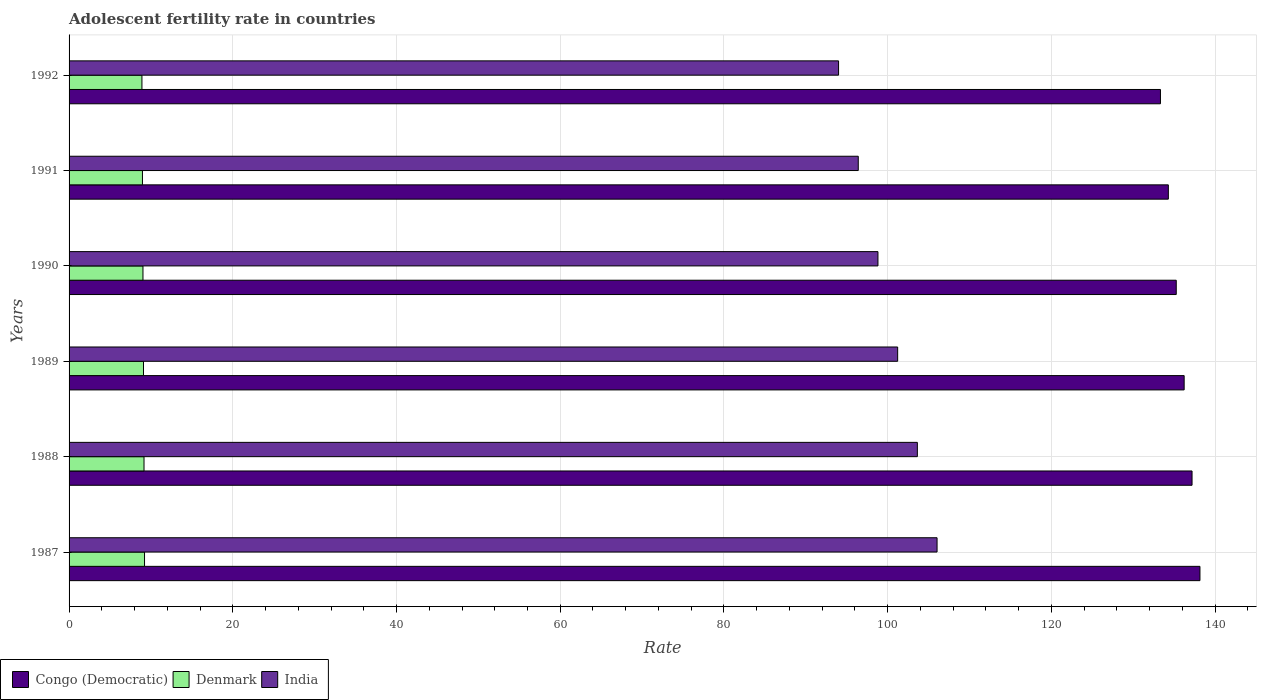How many different coloured bars are there?
Your response must be concise. 3. How many groups of bars are there?
Make the answer very short. 6. How many bars are there on the 6th tick from the top?
Ensure brevity in your answer.  3. How many bars are there on the 6th tick from the bottom?
Make the answer very short. 3. What is the label of the 5th group of bars from the top?
Make the answer very short. 1988. What is the adolescent fertility rate in India in 1989?
Keep it short and to the point. 101.22. Across all years, what is the maximum adolescent fertility rate in Denmark?
Offer a very short reply. 9.22. Across all years, what is the minimum adolescent fertility rate in Denmark?
Provide a short and direct response. 8.9. In which year was the adolescent fertility rate in Congo (Democratic) maximum?
Your answer should be very brief. 1987. In which year was the adolescent fertility rate in Denmark minimum?
Offer a very short reply. 1992. What is the total adolescent fertility rate in Congo (Democratic) in the graph?
Your answer should be compact. 814.41. What is the difference between the adolescent fertility rate in Denmark in 1988 and that in 1989?
Your answer should be very brief. 0.06. What is the difference between the adolescent fertility rate in India in 1990 and the adolescent fertility rate in Denmark in 1991?
Provide a short and direct response. 89.85. What is the average adolescent fertility rate in Congo (Democratic) per year?
Keep it short and to the point. 135.73. In the year 1987, what is the difference between the adolescent fertility rate in Denmark and adolescent fertility rate in India?
Keep it short and to the point. -96.81. What is the ratio of the adolescent fertility rate in India in 1988 to that in 1991?
Make the answer very short. 1.07. Is the adolescent fertility rate in India in 1988 less than that in 1991?
Provide a succinct answer. No. What is the difference between the highest and the second highest adolescent fertility rate in Denmark?
Your answer should be compact. 0.06. What is the difference between the highest and the lowest adolescent fertility rate in Congo (Democratic)?
Offer a terse response. 4.82. In how many years, is the adolescent fertility rate in India greater than the average adolescent fertility rate in India taken over all years?
Offer a terse response. 3. What does the 2nd bar from the top in 1992 represents?
Make the answer very short. Denmark. What does the 3rd bar from the bottom in 1987 represents?
Your response must be concise. India. How many bars are there?
Provide a succinct answer. 18. Are all the bars in the graph horizontal?
Give a very brief answer. Yes. What is the difference between two consecutive major ticks on the X-axis?
Your answer should be compact. 20. Does the graph contain grids?
Provide a succinct answer. Yes. What is the title of the graph?
Offer a very short reply. Adolescent fertility rate in countries. Does "Thailand" appear as one of the legend labels in the graph?
Offer a very short reply. No. What is the label or title of the X-axis?
Your answer should be very brief. Rate. What is the Rate in Congo (Democratic) in 1987?
Ensure brevity in your answer.  138.15. What is the Rate of Denmark in 1987?
Keep it short and to the point. 9.22. What is the Rate in India in 1987?
Offer a terse response. 106.03. What is the Rate of Congo (Democratic) in 1988?
Your answer should be very brief. 137.18. What is the Rate in Denmark in 1988?
Your answer should be very brief. 9.16. What is the Rate of India in 1988?
Provide a short and direct response. 103.63. What is the Rate of Congo (Democratic) in 1989?
Your answer should be compact. 136.22. What is the Rate of Denmark in 1989?
Your answer should be very brief. 9.09. What is the Rate of India in 1989?
Your answer should be compact. 101.22. What is the Rate of Congo (Democratic) in 1990?
Ensure brevity in your answer.  135.25. What is the Rate of Denmark in 1990?
Your answer should be very brief. 9.03. What is the Rate in India in 1990?
Make the answer very short. 98.81. What is the Rate in Congo (Democratic) in 1991?
Provide a short and direct response. 134.29. What is the Rate of Denmark in 1991?
Your answer should be very brief. 8.96. What is the Rate in India in 1991?
Your answer should be compact. 96.41. What is the Rate in Congo (Democratic) in 1992?
Give a very brief answer. 133.32. What is the Rate in Denmark in 1992?
Offer a terse response. 8.9. What is the Rate of India in 1992?
Give a very brief answer. 94. Across all years, what is the maximum Rate in Congo (Democratic)?
Ensure brevity in your answer.  138.15. Across all years, what is the maximum Rate of Denmark?
Keep it short and to the point. 9.22. Across all years, what is the maximum Rate of India?
Provide a short and direct response. 106.03. Across all years, what is the minimum Rate in Congo (Democratic)?
Ensure brevity in your answer.  133.32. Across all years, what is the minimum Rate in Denmark?
Offer a very short reply. 8.9. Across all years, what is the minimum Rate of India?
Provide a succinct answer. 94. What is the total Rate in Congo (Democratic) in the graph?
Make the answer very short. 814.41. What is the total Rate of Denmark in the graph?
Offer a terse response. 54.36. What is the total Rate in India in the graph?
Give a very brief answer. 600.1. What is the difference between the Rate of Congo (Democratic) in 1987 and that in 1988?
Provide a short and direct response. 0.96. What is the difference between the Rate in Denmark in 1987 and that in 1988?
Provide a succinct answer. 0.06. What is the difference between the Rate of India in 1987 and that in 1988?
Your answer should be compact. 2.41. What is the difference between the Rate of Congo (Democratic) in 1987 and that in 1989?
Offer a very short reply. 1.93. What is the difference between the Rate of Denmark in 1987 and that in 1989?
Ensure brevity in your answer.  0.13. What is the difference between the Rate in India in 1987 and that in 1989?
Make the answer very short. 4.81. What is the difference between the Rate in Congo (Democratic) in 1987 and that in 1990?
Provide a short and direct response. 2.9. What is the difference between the Rate in Denmark in 1987 and that in 1990?
Provide a succinct answer. 0.19. What is the difference between the Rate of India in 1987 and that in 1990?
Provide a short and direct response. 7.22. What is the difference between the Rate of Congo (Democratic) in 1987 and that in 1991?
Offer a terse response. 3.86. What is the difference between the Rate in Denmark in 1987 and that in 1991?
Ensure brevity in your answer.  0.25. What is the difference between the Rate of India in 1987 and that in 1991?
Keep it short and to the point. 9.63. What is the difference between the Rate of Congo (Democratic) in 1987 and that in 1992?
Offer a very short reply. 4.83. What is the difference between the Rate of Denmark in 1987 and that in 1992?
Your answer should be very brief. 0.32. What is the difference between the Rate in India in 1987 and that in 1992?
Give a very brief answer. 12.03. What is the difference between the Rate of Denmark in 1988 and that in 1989?
Your answer should be compact. 0.06. What is the difference between the Rate of India in 1988 and that in 1989?
Your answer should be very brief. 2.41. What is the difference between the Rate in Congo (Democratic) in 1988 and that in 1990?
Provide a short and direct response. 1.93. What is the difference between the Rate in Denmark in 1988 and that in 1990?
Keep it short and to the point. 0.13. What is the difference between the Rate of India in 1988 and that in 1990?
Keep it short and to the point. 4.81. What is the difference between the Rate of Congo (Democratic) in 1988 and that in 1991?
Offer a terse response. 2.9. What is the difference between the Rate of Denmark in 1988 and that in 1991?
Make the answer very short. 0.19. What is the difference between the Rate of India in 1988 and that in 1991?
Offer a very short reply. 7.22. What is the difference between the Rate of Congo (Democratic) in 1988 and that in 1992?
Provide a short and direct response. 3.86. What is the difference between the Rate of Denmark in 1988 and that in 1992?
Your answer should be compact. 0.25. What is the difference between the Rate in India in 1988 and that in 1992?
Ensure brevity in your answer.  9.63. What is the difference between the Rate in Congo (Democratic) in 1989 and that in 1990?
Offer a terse response. 0.96. What is the difference between the Rate of Denmark in 1989 and that in 1990?
Provide a succinct answer. 0.06. What is the difference between the Rate of India in 1989 and that in 1990?
Make the answer very short. 2.41. What is the difference between the Rate in Congo (Democratic) in 1989 and that in 1991?
Make the answer very short. 1.93. What is the difference between the Rate of Denmark in 1989 and that in 1991?
Make the answer very short. 0.13. What is the difference between the Rate of India in 1989 and that in 1991?
Ensure brevity in your answer.  4.81. What is the difference between the Rate in Congo (Democratic) in 1989 and that in 1992?
Give a very brief answer. 2.9. What is the difference between the Rate in Denmark in 1989 and that in 1992?
Ensure brevity in your answer.  0.19. What is the difference between the Rate of India in 1989 and that in 1992?
Your response must be concise. 7.22. What is the difference between the Rate of Congo (Democratic) in 1990 and that in 1991?
Your answer should be compact. 0.96. What is the difference between the Rate of Denmark in 1990 and that in 1991?
Ensure brevity in your answer.  0.06. What is the difference between the Rate in India in 1990 and that in 1991?
Your response must be concise. 2.41. What is the difference between the Rate in Congo (Democratic) in 1990 and that in 1992?
Your answer should be very brief. 1.93. What is the difference between the Rate in Denmark in 1990 and that in 1992?
Your answer should be very brief. 0.13. What is the difference between the Rate of India in 1990 and that in 1992?
Make the answer very short. 4.81. What is the difference between the Rate in Congo (Democratic) in 1991 and that in 1992?
Provide a short and direct response. 0.96. What is the difference between the Rate of Denmark in 1991 and that in 1992?
Make the answer very short. 0.06. What is the difference between the Rate of India in 1991 and that in 1992?
Offer a very short reply. 2.41. What is the difference between the Rate in Congo (Democratic) in 1987 and the Rate in Denmark in 1988?
Ensure brevity in your answer.  128.99. What is the difference between the Rate of Congo (Democratic) in 1987 and the Rate of India in 1988?
Provide a succinct answer. 34.52. What is the difference between the Rate of Denmark in 1987 and the Rate of India in 1988?
Provide a short and direct response. -94.41. What is the difference between the Rate in Congo (Democratic) in 1987 and the Rate in Denmark in 1989?
Your answer should be compact. 129.06. What is the difference between the Rate in Congo (Democratic) in 1987 and the Rate in India in 1989?
Your answer should be very brief. 36.93. What is the difference between the Rate in Denmark in 1987 and the Rate in India in 1989?
Provide a short and direct response. -92. What is the difference between the Rate in Congo (Democratic) in 1987 and the Rate in Denmark in 1990?
Offer a terse response. 129.12. What is the difference between the Rate of Congo (Democratic) in 1987 and the Rate of India in 1990?
Make the answer very short. 39.33. What is the difference between the Rate of Denmark in 1987 and the Rate of India in 1990?
Offer a very short reply. -89.59. What is the difference between the Rate of Congo (Democratic) in 1987 and the Rate of Denmark in 1991?
Your answer should be very brief. 129.18. What is the difference between the Rate of Congo (Democratic) in 1987 and the Rate of India in 1991?
Keep it short and to the point. 41.74. What is the difference between the Rate in Denmark in 1987 and the Rate in India in 1991?
Offer a terse response. -87.19. What is the difference between the Rate of Congo (Democratic) in 1987 and the Rate of Denmark in 1992?
Your answer should be very brief. 129.25. What is the difference between the Rate of Congo (Democratic) in 1987 and the Rate of India in 1992?
Your response must be concise. 44.15. What is the difference between the Rate of Denmark in 1987 and the Rate of India in 1992?
Offer a terse response. -84.78. What is the difference between the Rate in Congo (Democratic) in 1988 and the Rate in Denmark in 1989?
Provide a short and direct response. 128.09. What is the difference between the Rate in Congo (Democratic) in 1988 and the Rate in India in 1989?
Your answer should be very brief. 35.96. What is the difference between the Rate in Denmark in 1988 and the Rate in India in 1989?
Give a very brief answer. -92.06. What is the difference between the Rate of Congo (Democratic) in 1988 and the Rate of Denmark in 1990?
Offer a terse response. 128.15. What is the difference between the Rate in Congo (Democratic) in 1988 and the Rate in India in 1990?
Your answer should be compact. 38.37. What is the difference between the Rate in Denmark in 1988 and the Rate in India in 1990?
Your answer should be very brief. -89.66. What is the difference between the Rate in Congo (Democratic) in 1988 and the Rate in Denmark in 1991?
Provide a short and direct response. 128.22. What is the difference between the Rate of Congo (Democratic) in 1988 and the Rate of India in 1991?
Your answer should be compact. 40.78. What is the difference between the Rate in Denmark in 1988 and the Rate in India in 1991?
Make the answer very short. -87.25. What is the difference between the Rate of Congo (Democratic) in 1988 and the Rate of Denmark in 1992?
Keep it short and to the point. 128.28. What is the difference between the Rate in Congo (Democratic) in 1988 and the Rate in India in 1992?
Make the answer very short. 43.18. What is the difference between the Rate of Denmark in 1988 and the Rate of India in 1992?
Make the answer very short. -84.84. What is the difference between the Rate of Congo (Democratic) in 1989 and the Rate of Denmark in 1990?
Provide a short and direct response. 127.19. What is the difference between the Rate in Congo (Democratic) in 1989 and the Rate in India in 1990?
Your answer should be compact. 37.4. What is the difference between the Rate in Denmark in 1989 and the Rate in India in 1990?
Offer a terse response. -89.72. What is the difference between the Rate of Congo (Democratic) in 1989 and the Rate of Denmark in 1991?
Offer a very short reply. 127.25. What is the difference between the Rate in Congo (Democratic) in 1989 and the Rate in India in 1991?
Provide a short and direct response. 39.81. What is the difference between the Rate of Denmark in 1989 and the Rate of India in 1991?
Give a very brief answer. -87.31. What is the difference between the Rate in Congo (Democratic) in 1989 and the Rate in Denmark in 1992?
Keep it short and to the point. 127.32. What is the difference between the Rate of Congo (Democratic) in 1989 and the Rate of India in 1992?
Provide a short and direct response. 42.22. What is the difference between the Rate of Denmark in 1989 and the Rate of India in 1992?
Offer a terse response. -84.91. What is the difference between the Rate of Congo (Democratic) in 1990 and the Rate of Denmark in 1991?
Provide a short and direct response. 126.29. What is the difference between the Rate of Congo (Democratic) in 1990 and the Rate of India in 1991?
Offer a very short reply. 38.85. What is the difference between the Rate of Denmark in 1990 and the Rate of India in 1991?
Provide a short and direct response. -87.38. What is the difference between the Rate in Congo (Democratic) in 1990 and the Rate in Denmark in 1992?
Provide a succinct answer. 126.35. What is the difference between the Rate in Congo (Democratic) in 1990 and the Rate in India in 1992?
Keep it short and to the point. 41.25. What is the difference between the Rate of Denmark in 1990 and the Rate of India in 1992?
Provide a succinct answer. -84.97. What is the difference between the Rate in Congo (Democratic) in 1991 and the Rate in Denmark in 1992?
Provide a short and direct response. 125.39. What is the difference between the Rate of Congo (Democratic) in 1991 and the Rate of India in 1992?
Provide a succinct answer. 40.29. What is the difference between the Rate of Denmark in 1991 and the Rate of India in 1992?
Offer a terse response. -85.04. What is the average Rate in Congo (Democratic) per year?
Offer a very short reply. 135.73. What is the average Rate of Denmark per year?
Your response must be concise. 9.06. What is the average Rate in India per year?
Provide a succinct answer. 100.02. In the year 1987, what is the difference between the Rate of Congo (Democratic) and Rate of Denmark?
Give a very brief answer. 128.93. In the year 1987, what is the difference between the Rate of Congo (Democratic) and Rate of India?
Offer a very short reply. 32.11. In the year 1987, what is the difference between the Rate of Denmark and Rate of India?
Ensure brevity in your answer.  -96.81. In the year 1988, what is the difference between the Rate of Congo (Democratic) and Rate of Denmark?
Offer a terse response. 128.03. In the year 1988, what is the difference between the Rate of Congo (Democratic) and Rate of India?
Your response must be concise. 33.56. In the year 1988, what is the difference between the Rate in Denmark and Rate in India?
Offer a very short reply. -94.47. In the year 1989, what is the difference between the Rate in Congo (Democratic) and Rate in Denmark?
Your answer should be very brief. 127.13. In the year 1989, what is the difference between the Rate of Congo (Democratic) and Rate of India?
Make the answer very short. 35. In the year 1989, what is the difference between the Rate of Denmark and Rate of India?
Keep it short and to the point. -92.13. In the year 1990, what is the difference between the Rate in Congo (Democratic) and Rate in Denmark?
Your answer should be compact. 126.22. In the year 1990, what is the difference between the Rate in Congo (Democratic) and Rate in India?
Provide a short and direct response. 36.44. In the year 1990, what is the difference between the Rate in Denmark and Rate in India?
Your response must be concise. -89.78. In the year 1991, what is the difference between the Rate of Congo (Democratic) and Rate of Denmark?
Your response must be concise. 125.32. In the year 1991, what is the difference between the Rate of Congo (Democratic) and Rate of India?
Your response must be concise. 37.88. In the year 1991, what is the difference between the Rate of Denmark and Rate of India?
Offer a very short reply. -87.44. In the year 1992, what is the difference between the Rate in Congo (Democratic) and Rate in Denmark?
Your answer should be compact. 124.42. In the year 1992, what is the difference between the Rate in Congo (Democratic) and Rate in India?
Offer a terse response. 39.32. In the year 1992, what is the difference between the Rate in Denmark and Rate in India?
Offer a terse response. -85.1. What is the ratio of the Rate in Denmark in 1987 to that in 1988?
Ensure brevity in your answer.  1.01. What is the ratio of the Rate in India in 1987 to that in 1988?
Your response must be concise. 1.02. What is the ratio of the Rate in Congo (Democratic) in 1987 to that in 1989?
Give a very brief answer. 1.01. What is the ratio of the Rate of India in 1987 to that in 1989?
Your answer should be compact. 1.05. What is the ratio of the Rate of Congo (Democratic) in 1987 to that in 1990?
Keep it short and to the point. 1.02. What is the ratio of the Rate of Denmark in 1987 to that in 1990?
Ensure brevity in your answer.  1.02. What is the ratio of the Rate of India in 1987 to that in 1990?
Your answer should be compact. 1.07. What is the ratio of the Rate of Congo (Democratic) in 1987 to that in 1991?
Give a very brief answer. 1.03. What is the ratio of the Rate of Denmark in 1987 to that in 1991?
Your response must be concise. 1.03. What is the ratio of the Rate of India in 1987 to that in 1991?
Provide a short and direct response. 1.1. What is the ratio of the Rate in Congo (Democratic) in 1987 to that in 1992?
Your answer should be compact. 1.04. What is the ratio of the Rate of Denmark in 1987 to that in 1992?
Your response must be concise. 1.04. What is the ratio of the Rate of India in 1987 to that in 1992?
Your answer should be very brief. 1.13. What is the ratio of the Rate of Congo (Democratic) in 1988 to that in 1989?
Your response must be concise. 1.01. What is the ratio of the Rate in India in 1988 to that in 1989?
Offer a terse response. 1.02. What is the ratio of the Rate of Congo (Democratic) in 1988 to that in 1990?
Provide a succinct answer. 1.01. What is the ratio of the Rate of Denmark in 1988 to that in 1990?
Give a very brief answer. 1.01. What is the ratio of the Rate in India in 1988 to that in 1990?
Ensure brevity in your answer.  1.05. What is the ratio of the Rate in Congo (Democratic) in 1988 to that in 1991?
Your response must be concise. 1.02. What is the ratio of the Rate of Denmark in 1988 to that in 1991?
Make the answer very short. 1.02. What is the ratio of the Rate in India in 1988 to that in 1991?
Keep it short and to the point. 1.07. What is the ratio of the Rate in Congo (Democratic) in 1988 to that in 1992?
Your answer should be very brief. 1.03. What is the ratio of the Rate of Denmark in 1988 to that in 1992?
Your answer should be compact. 1.03. What is the ratio of the Rate of India in 1988 to that in 1992?
Your answer should be compact. 1.1. What is the ratio of the Rate in Congo (Democratic) in 1989 to that in 1990?
Provide a short and direct response. 1.01. What is the ratio of the Rate of Denmark in 1989 to that in 1990?
Keep it short and to the point. 1.01. What is the ratio of the Rate in India in 1989 to that in 1990?
Keep it short and to the point. 1.02. What is the ratio of the Rate in Congo (Democratic) in 1989 to that in 1991?
Your answer should be compact. 1.01. What is the ratio of the Rate in Denmark in 1989 to that in 1991?
Ensure brevity in your answer.  1.01. What is the ratio of the Rate of India in 1989 to that in 1991?
Your answer should be compact. 1.05. What is the ratio of the Rate of Congo (Democratic) in 1989 to that in 1992?
Offer a very short reply. 1.02. What is the ratio of the Rate of Denmark in 1989 to that in 1992?
Provide a succinct answer. 1.02. What is the ratio of the Rate of India in 1989 to that in 1992?
Offer a terse response. 1.08. What is the ratio of the Rate in Congo (Democratic) in 1990 to that in 1991?
Keep it short and to the point. 1.01. What is the ratio of the Rate of Denmark in 1990 to that in 1991?
Offer a very short reply. 1.01. What is the ratio of the Rate of Congo (Democratic) in 1990 to that in 1992?
Your answer should be compact. 1.01. What is the ratio of the Rate in Denmark in 1990 to that in 1992?
Your answer should be very brief. 1.01. What is the ratio of the Rate in India in 1990 to that in 1992?
Ensure brevity in your answer.  1.05. What is the ratio of the Rate in Congo (Democratic) in 1991 to that in 1992?
Your answer should be compact. 1.01. What is the ratio of the Rate of Denmark in 1991 to that in 1992?
Give a very brief answer. 1.01. What is the ratio of the Rate of India in 1991 to that in 1992?
Offer a terse response. 1.03. What is the difference between the highest and the second highest Rate of Congo (Democratic)?
Your response must be concise. 0.96. What is the difference between the highest and the second highest Rate of Denmark?
Offer a very short reply. 0.06. What is the difference between the highest and the second highest Rate in India?
Keep it short and to the point. 2.41. What is the difference between the highest and the lowest Rate of Congo (Democratic)?
Your answer should be compact. 4.83. What is the difference between the highest and the lowest Rate of Denmark?
Make the answer very short. 0.32. What is the difference between the highest and the lowest Rate in India?
Keep it short and to the point. 12.03. 